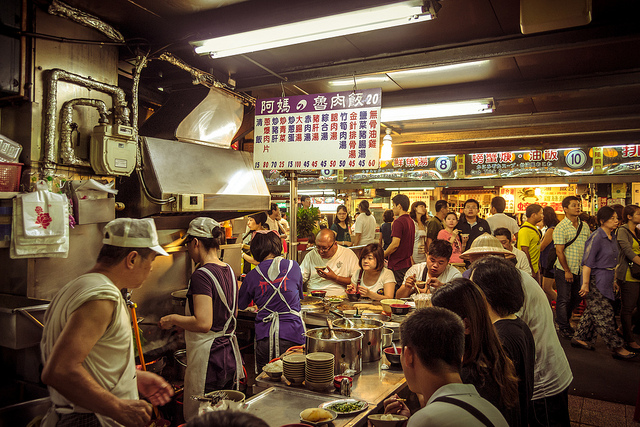Identify the text displayed in this image. 8 10 55 45 5 0 45 20 